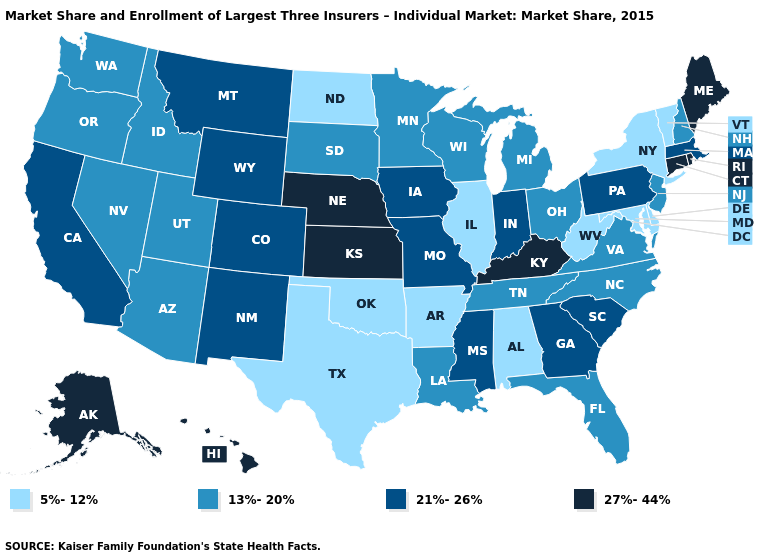What is the value of West Virginia?
Concise answer only. 5%-12%. Name the states that have a value in the range 5%-12%?
Answer briefly. Alabama, Arkansas, Delaware, Illinois, Maryland, New York, North Dakota, Oklahoma, Texas, Vermont, West Virginia. Does Nebraska have the highest value in the MidWest?
Be succinct. Yes. How many symbols are there in the legend?
Answer briefly. 4. What is the value of Washington?
Concise answer only. 13%-20%. Among the states that border Maryland , which have the lowest value?
Concise answer only. Delaware, West Virginia. What is the lowest value in the MidWest?
Be succinct. 5%-12%. Does Vermont have the lowest value in the USA?
Quick response, please. Yes. What is the lowest value in states that border Minnesota?
Short answer required. 5%-12%. What is the lowest value in the South?
Concise answer only. 5%-12%. Does Alaska have a higher value than Montana?
Answer briefly. Yes. Which states have the highest value in the USA?
Be succinct. Alaska, Connecticut, Hawaii, Kansas, Kentucky, Maine, Nebraska, Rhode Island. Does Rhode Island have the highest value in the Northeast?
Be succinct. Yes. What is the value of Delaware?
Short answer required. 5%-12%. 